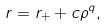<formula> <loc_0><loc_0><loc_500><loc_500>r = r _ { + } + c \rho ^ { q } ,</formula> 